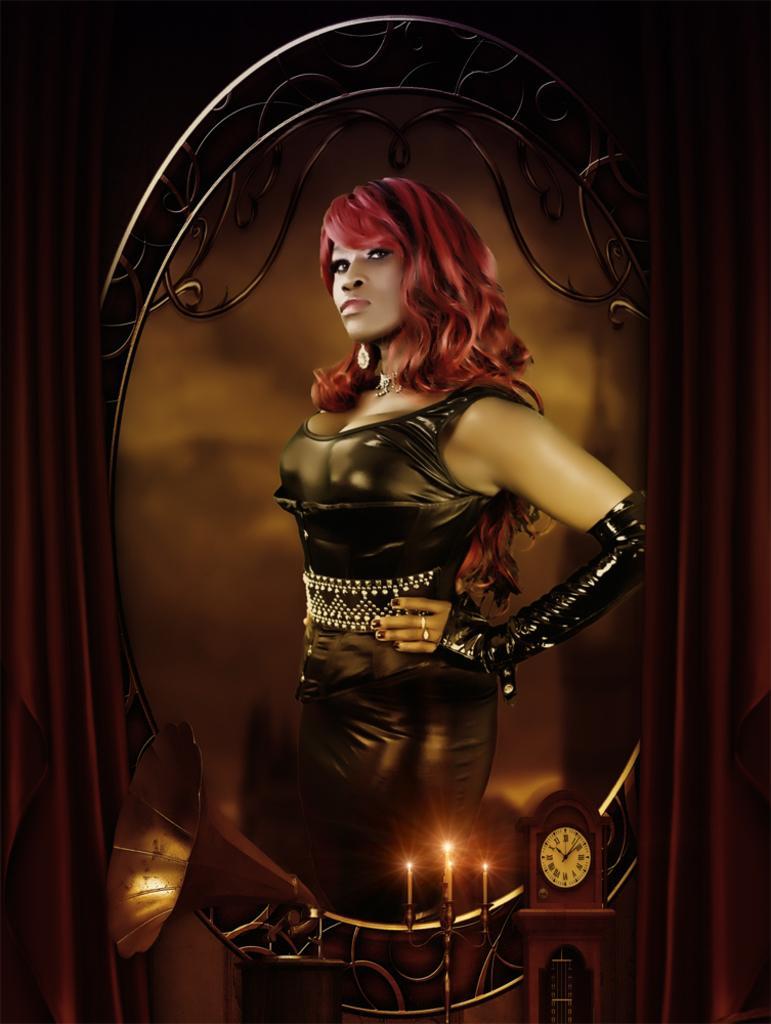How would you summarize this image in a sentence or two? In the image we can see there is a woman and there are candles kept on the stand. There is a clock and there is a music system. There are curtains. 